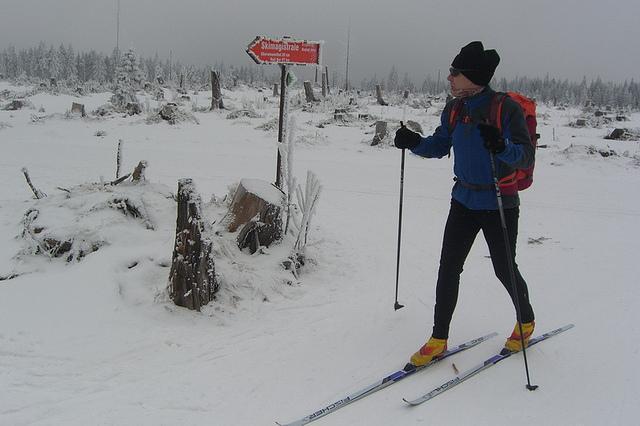How many people can be seen?
Give a very brief answer. 1. 